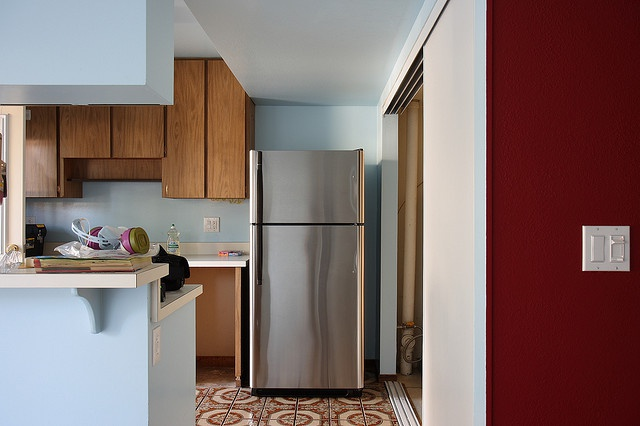Describe the objects in this image and their specific colors. I can see refrigerator in darkgray, gray, and black tones, book in darkgray, gray, tan, and black tones, and bottle in darkgray and gray tones in this image. 